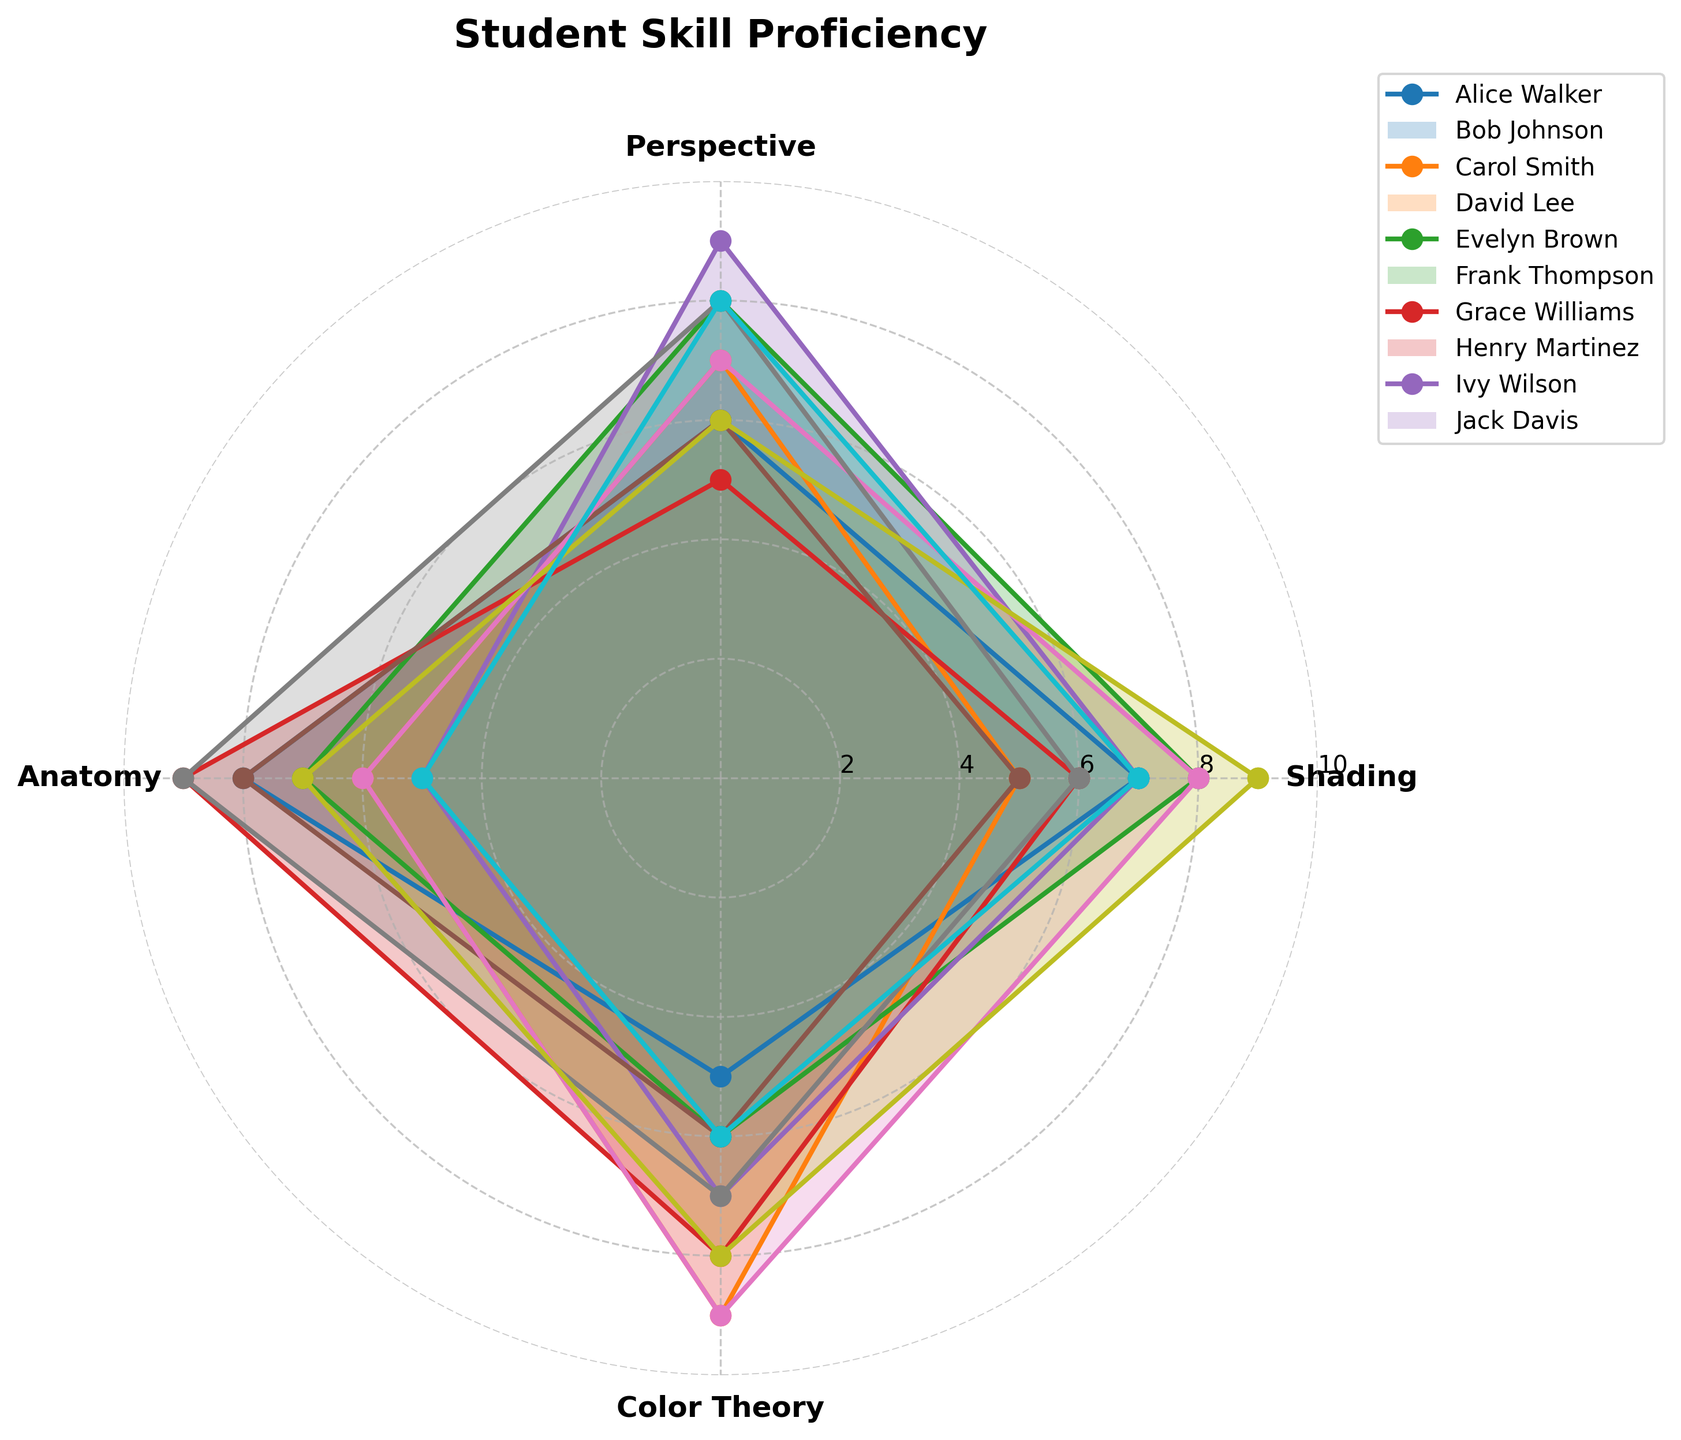What is the highest proficiency level in Shading? Look at the radar chart's Shading axis and find the maximum value plotted across all students.
Answer: 9 Which student shows the highest proficiency in Color Theory? Identify the student with the highest value on the Color Theory axis by comparing the plotted points.
Answer: Bob Johnson Which skill does Alice Walker have the highest proficiency in? Observe Alice Walker's proficiency levels on each axis and determine which one has the highest value.
Answer: Anatomy Who has the lowest proficiency in Anatomy? Compare the proficiency levels of all students on the Anatomy axis to find the lowest value.
Answer: Evelyn Brown What is the average proficiency level in Perspective for all students? Sum all students' Perspective proficiency levels and divide by the number of students: (6+7+8+5+9+6+7+8+6+8) / 10 = 70 / 10 = 7.
Answer: 7 Between Shading and Perspective, which skill has more students with proficiency levels of 8 or higher? Count the number of students with at least 8 in Shading and in Perspective and compare the counts: Shading - 3 (Carol, Grace, Ivy); Perspective - 4 (Carol, Evelyn, Henry, Jack).
Answer: Perspective Which student has the most balanced proficiency across all skills? Look for the student whose radar chart has fewer extreme values (i.e., similar proficiency levels in all skills).
Answer: Carol Smith Is there any student whose proficiency level in any skill is exactly equal to the average proficiency level for that skill across all students? Calculate the average for each skill: Shading = 6.8, Perspective = 7.0, Anatomy = 7.0, Color Theory = 7.0. Then, check for students with these exact values in any skill.
Answer: No What is the total proficiency score for David Lee across all skills? Sum David Lee's proficiency values for all skills: 6+5+9+8 = 28.
Answer: 28 